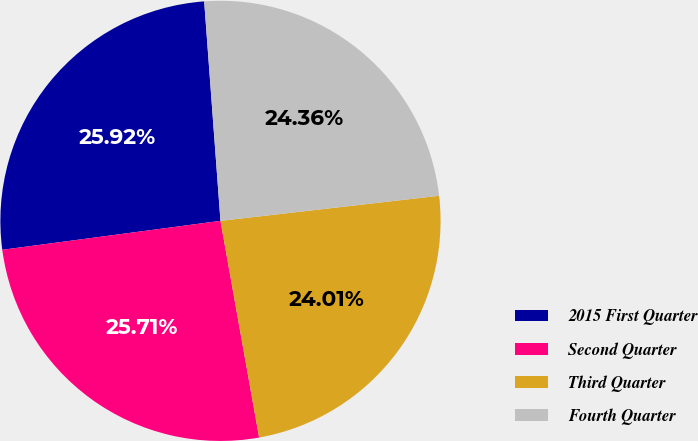Convert chart. <chart><loc_0><loc_0><loc_500><loc_500><pie_chart><fcel>2015 First Quarter<fcel>Second Quarter<fcel>Third Quarter<fcel>Fourth Quarter<nl><fcel>25.92%<fcel>25.71%<fcel>24.01%<fcel>24.36%<nl></chart> 